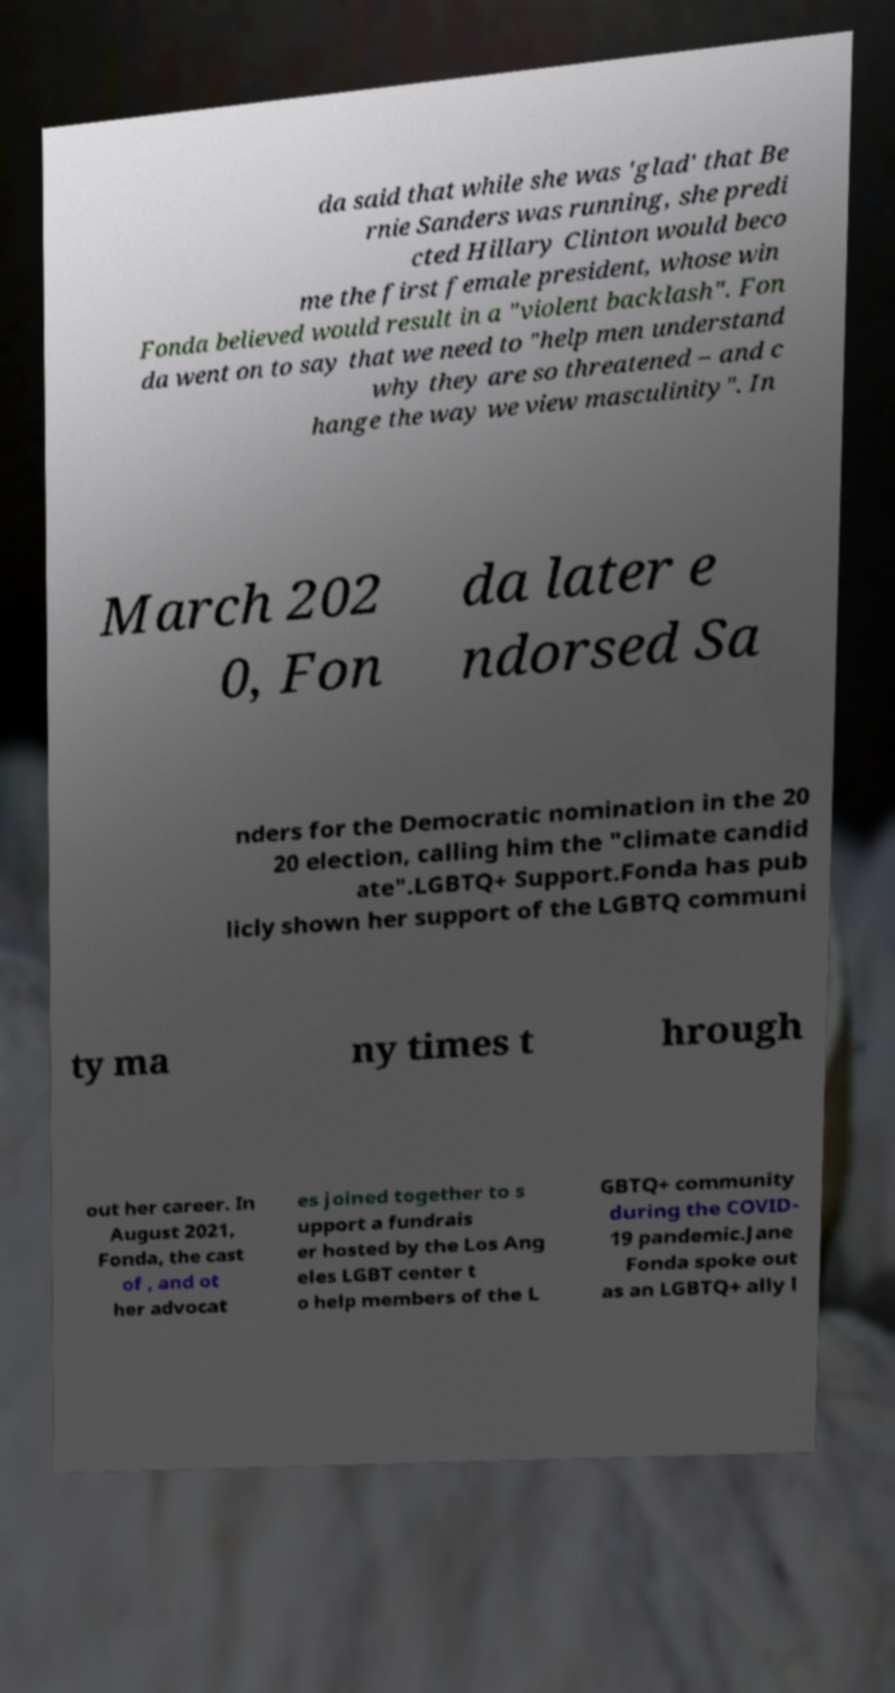Could you extract and type out the text from this image? da said that while she was 'glad' that Be rnie Sanders was running, she predi cted Hillary Clinton would beco me the first female president, whose win Fonda believed would result in a "violent backlash". Fon da went on to say that we need to "help men understand why they are so threatened – and c hange the way we view masculinity". In March 202 0, Fon da later e ndorsed Sa nders for the Democratic nomination in the 20 20 election, calling him the "climate candid ate".LGBTQ+ Support.Fonda has pub licly shown her support of the LGBTQ communi ty ma ny times t hrough out her career. In August 2021, Fonda, the cast of , and ot her advocat es joined together to s upport a fundrais er hosted by the Los Ang eles LGBT center t o help members of the L GBTQ+ community during the COVID- 19 pandemic.Jane Fonda spoke out as an LGBTQ+ ally l 